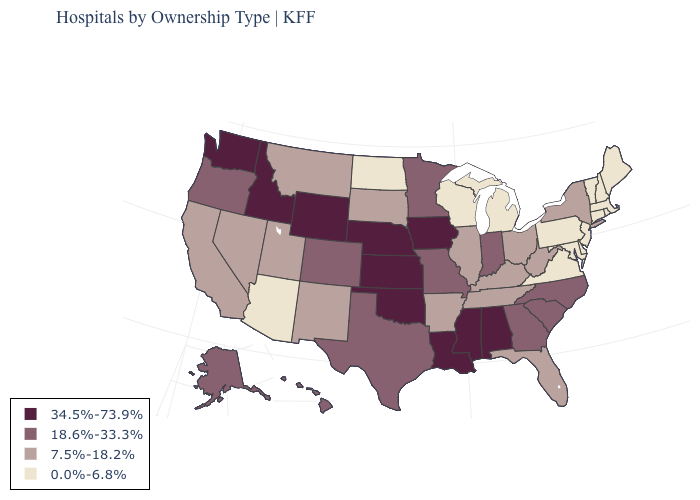What is the value of South Carolina?
Give a very brief answer. 18.6%-33.3%. Does the map have missing data?
Answer briefly. No. What is the value of Kansas?
Write a very short answer. 34.5%-73.9%. Does the first symbol in the legend represent the smallest category?
Answer briefly. No. Which states have the highest value in the USA?
Give a very brief answer. Alabama, Idaho, Iowa, Kansas, Louisiana, Mississippi, Nebraska, Oklahoma, Washington, Wyoming. Does Maine have a higher value than California?
Give a very brief answer. No. Among the states that border Kansas , which have the lowest value?
Quick response, please. Colorado, Missouri. Does Maryland have the lowest value in the South?
Concise answer only. Yes. What is the lowest value in the USA?
Answer briefly. 0.0%-6.8%. Name the states that have a value in the range 18.6%-33.3%?
Short answer required. Alaska, Colorado, Georgia, Hawaii, Indiana, Minnesota, Missouri, North Carolina, Oregon, South Carolina, Texas. What is the highest value in the USA?
Quick response, please. 34.5%-73.9%. What is the lowest value in states that border Pennsylvania?
Answer briefly. 0.0%-6.8%. What is the value of West Virginia?
Quick response, please. 7.5%-18.2%. What is the highest value in the Northeast ?
Give a very brief answer. 7.5%-18.2%. Name the states that have a value in the range 7.5%-18.2%?
Quick response, please. Arkansas, California, Florida, Illinois, Kentucky, Montana, Nevada, New Mexico, New York, Ohio, South Dakota, Tennessee, Utah, West Virginia. 